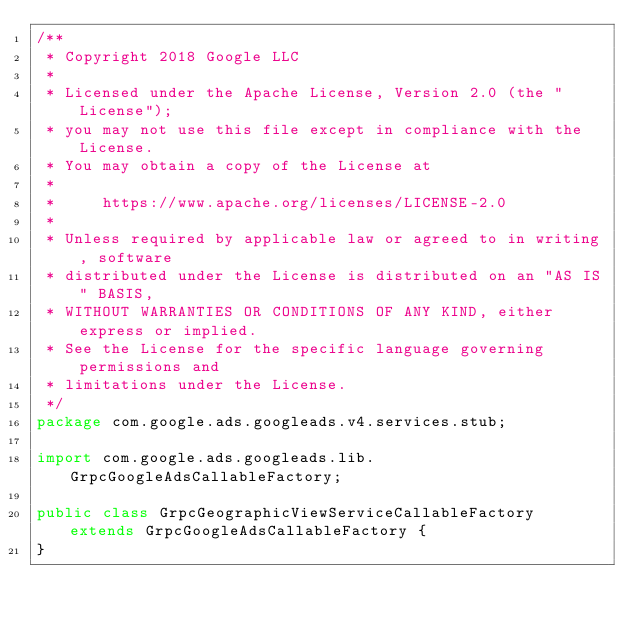<code> <loc_0><loc_0><loc_500><loc_500><_Java_>/**
 * Copyright 2018 Google LLC
 *
 * Licensed under the Apache License, Version 2.0 (the "License");
 * you may not use this file except in compliance with the License.
 * You may obtain a copy of the License at
 *
 *     https://www.apache.org/licenses/LICENSE-2.0
 *
 * Unless required by applicable law or agreed to in writing, software
 * distributed under the License is distributed on an "AS IS" BASIS,
 * WITHOUT WARRANTIES OR CONDITIONS OF ANY KIND, either express or implied.
 * See the License for the specific language governing permissions and
 * limitations under the License.
 */
package com.google.ads.googleads.v4.services.stub;

import com.google.ads.googleads.lib.GrpcGoogleAdsCallableFactory;

public class GrpcGeographicViewServiceCallableFactory extends GrpcGoogleAdsCallableFactory {
}
</code> 